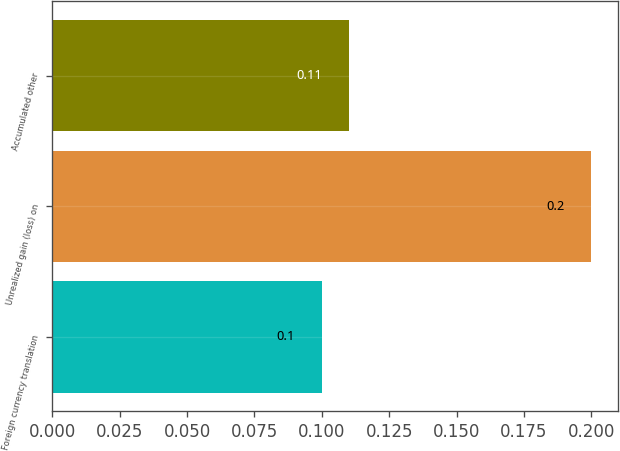Convert chart to OTSL. <chart><loc_0><loc_0><loc_500><loc_500><bar_chart><fcel>Foreign currency translation<fcel>Unrealized gain (loss) on<fcel>Accumulated other<nl><fcel>0.1<fcel>0.2<fcel>0.11<nl></chart> 